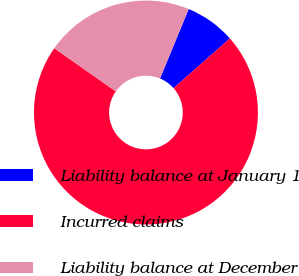Convert chart. <chart><loc_0><loc_0><loc_500><loc_500><pie_chart><fcel>Liability balance at January 1<fcel>Incurred claims<fcel>Liability balance at December<nl><fcel>7.26%<fcel>71.24%<fcel>21.5%<nl></chart> 